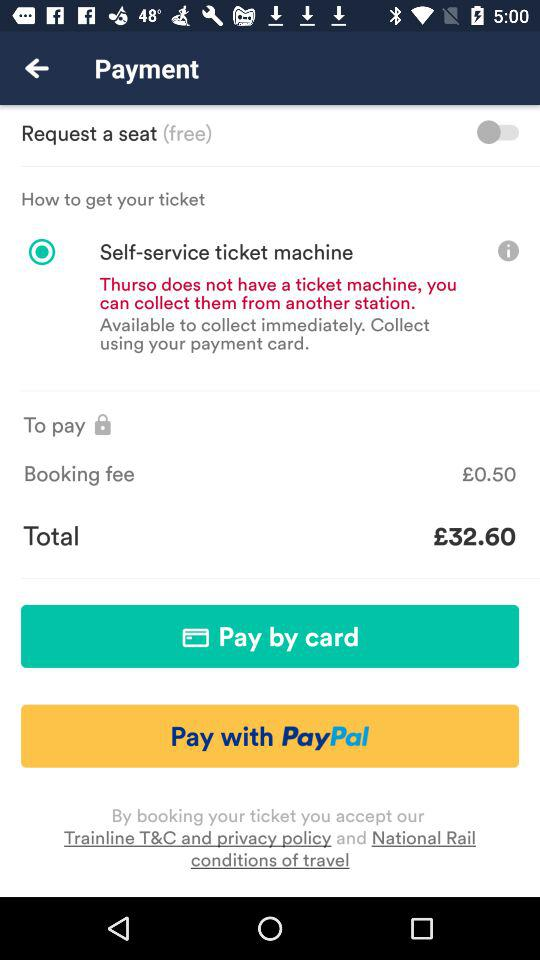How much is the total amount of the ticket?
Answer the question using a single word or phrase. £32.60 